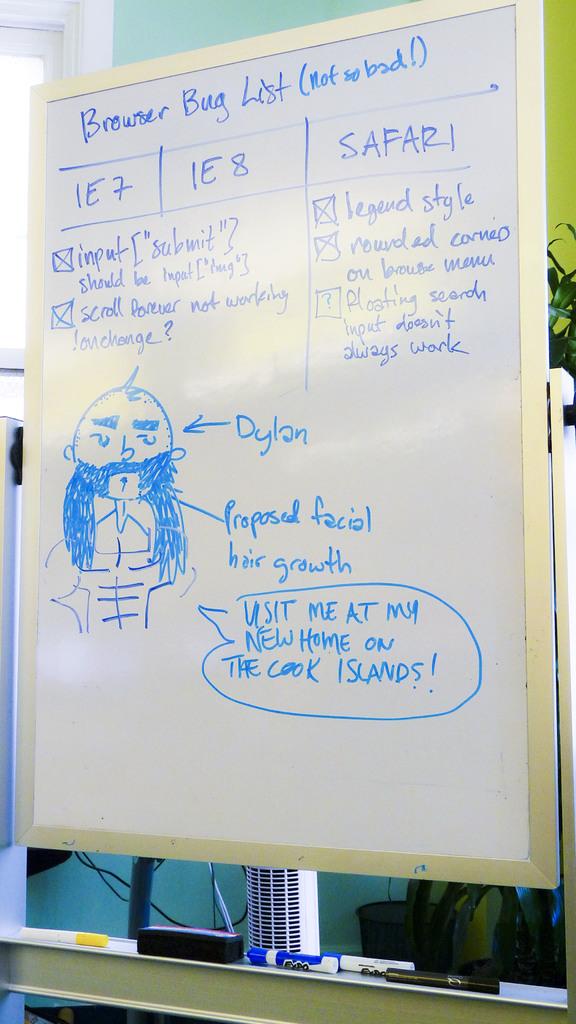Where is his new home?
Keep it short and to the point. The cook islands. What kind of list is at the top?
Ensure brevity in your answer.  Browser bug. 